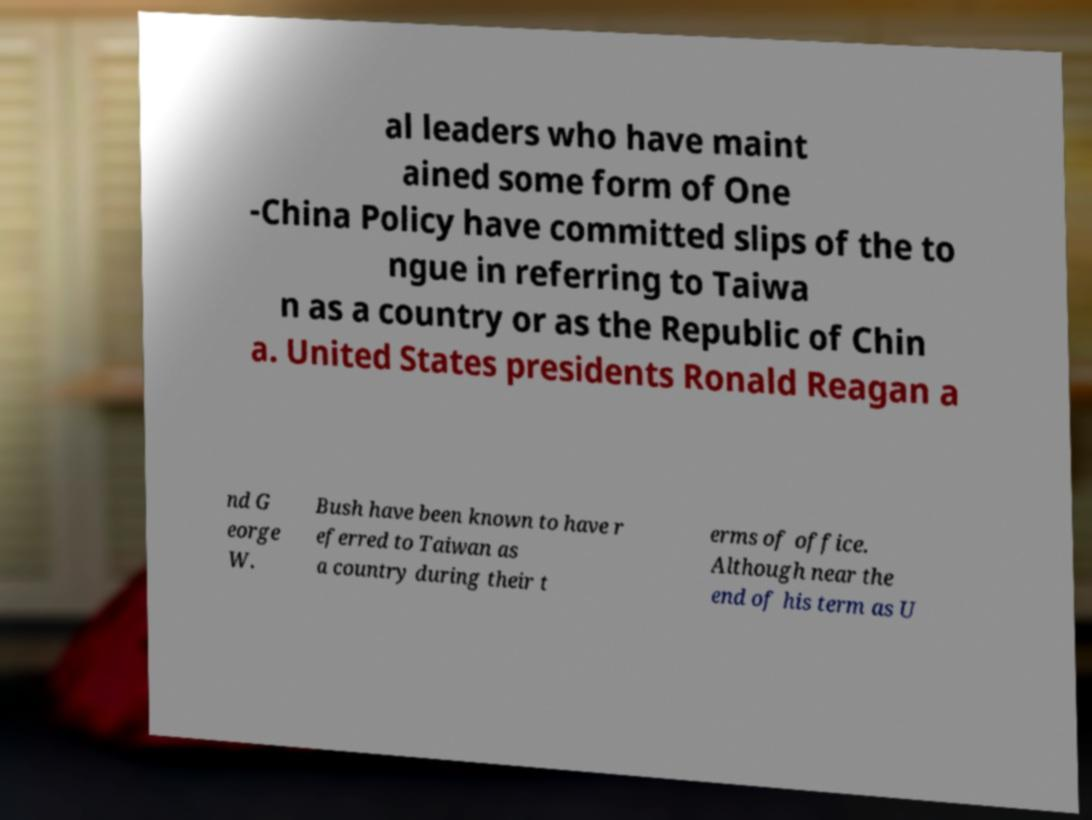What messages or text are displayed in this image? I need them in a readable, typed format. al leaders who have maint ained some form of One -China Policy have committed slips of the to ngue in referring to Taiwa n as a country or as the Republic of Chin a. United States presidents Ronald Reagan a nd G eorge W. Bush have been known to have r eferred to Taiwan as a country during their t erms of office. Although near the end of his term as U 